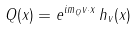<formula> <loc_0><loc_0><loc_500><loc_500>Q ( x ) = e ^ { i m _ { Q } v \cdot x } \, h _ { v } ( x )</formula> 